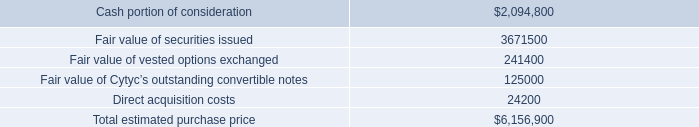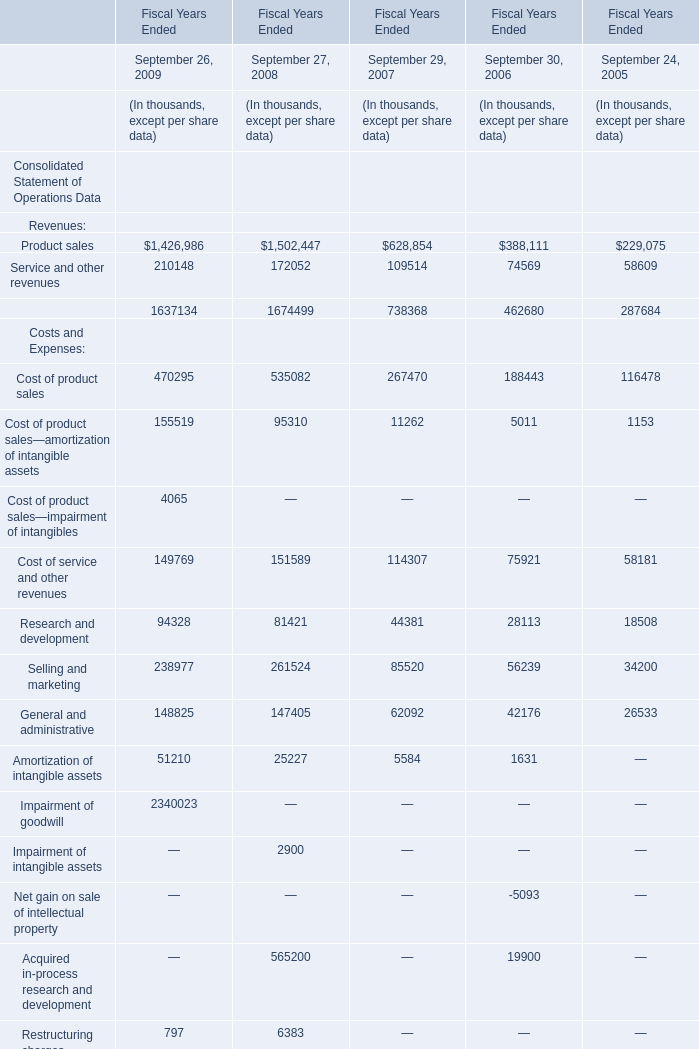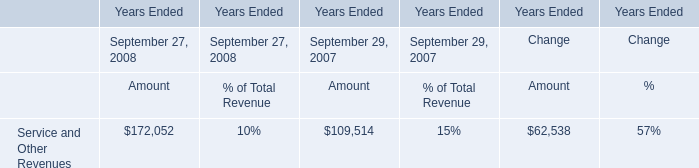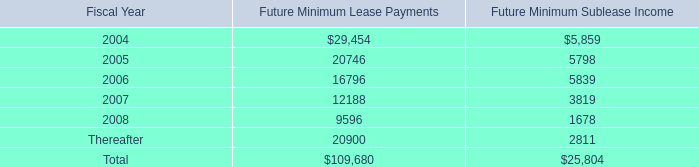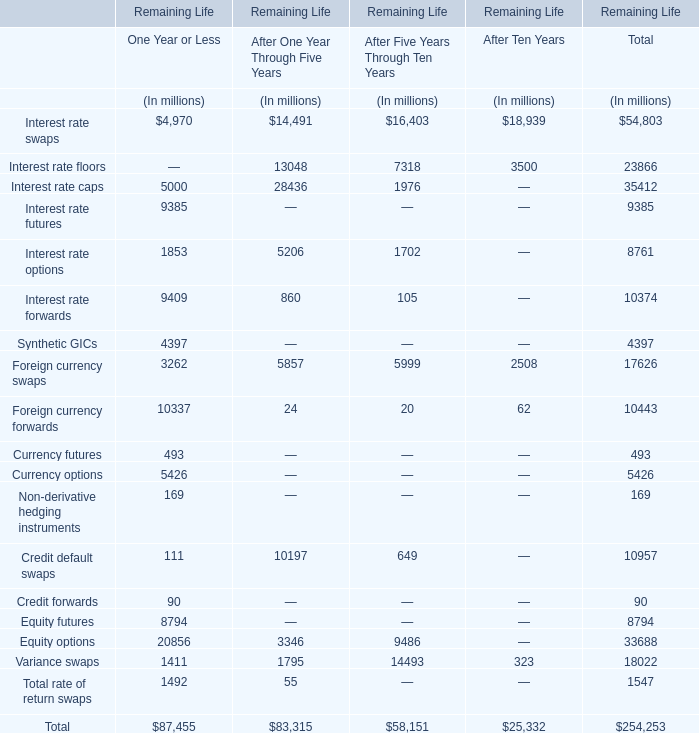what portion of the total estimated purchase price is paid in cash? 
Computations: (2094800 / 6156900)
Answer: 0.34024. 